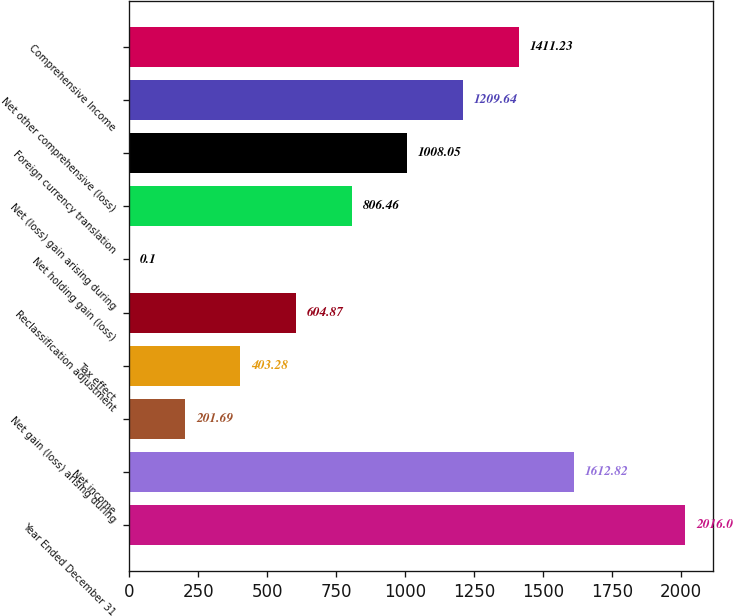Convert chart to OTSL. <chart><loc_0><loc_0><loc_500><loc_500><bar_chart><fcel>Year Ended December 31<fcel>Net income<fcel>Net gain (loss) arising during<fcel>Tax effect<fcel>Reclassification adjustment<fcel>Net holding gain (loss)<fcel>Net (loss) gain arising during<fcel>Foreign currency translation<fcel>Net other comprehensive (loss)<fcel>Comprehensive Income<nl><fcel>2016<fcel>1612.82<fcel>201.69<fcel>403.28<fcel>604.87<fcel>0.1<fcel>806.46<fcel>1008.05<fcel>1209.64<fcel>1411.23<nl></chart> 